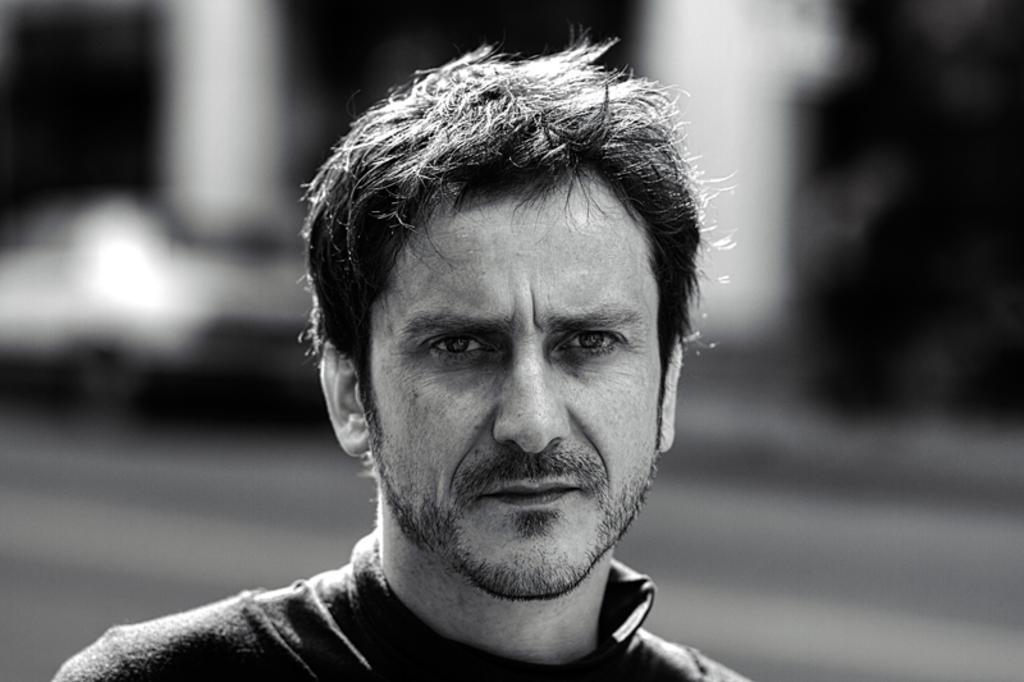Please provide a concise description of this image. In this picture there is a man who is wearing t-shirt. In the back I can see the blur image. In the background it might be the car on the road, beside that it might be the building and trees. 